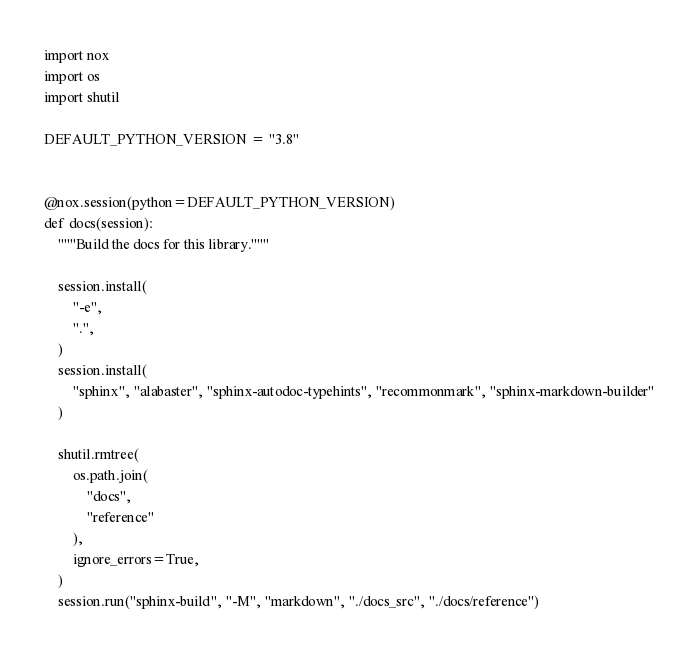Convert code to text. <code><loc_0><loc_0><loc_500><loc_500><_Python_>import nox
import os
import shutil

DEFAULT_PYTHON_VERSION = "3.8"


@nox.session(python=DEFAULT_PYTHON_VERSION)
def docs(session):
    """Build the docs for this library."""

    session.install(
        "-e",
        ".",
    )
    session.install(
        "sphinx", "alabaster", "sphinx-autodoc-typehints", "recommonmark", "sphinx-markdown-builder"
    )

    shutil.rmtree(
        os.path.join(
            "docs",
            "reference"
        ),
        ignore_errors=True,
    )
    session.run("sphinx-build", "-M", "markdown", "./docs_src", "./docs/reference")
</code> 